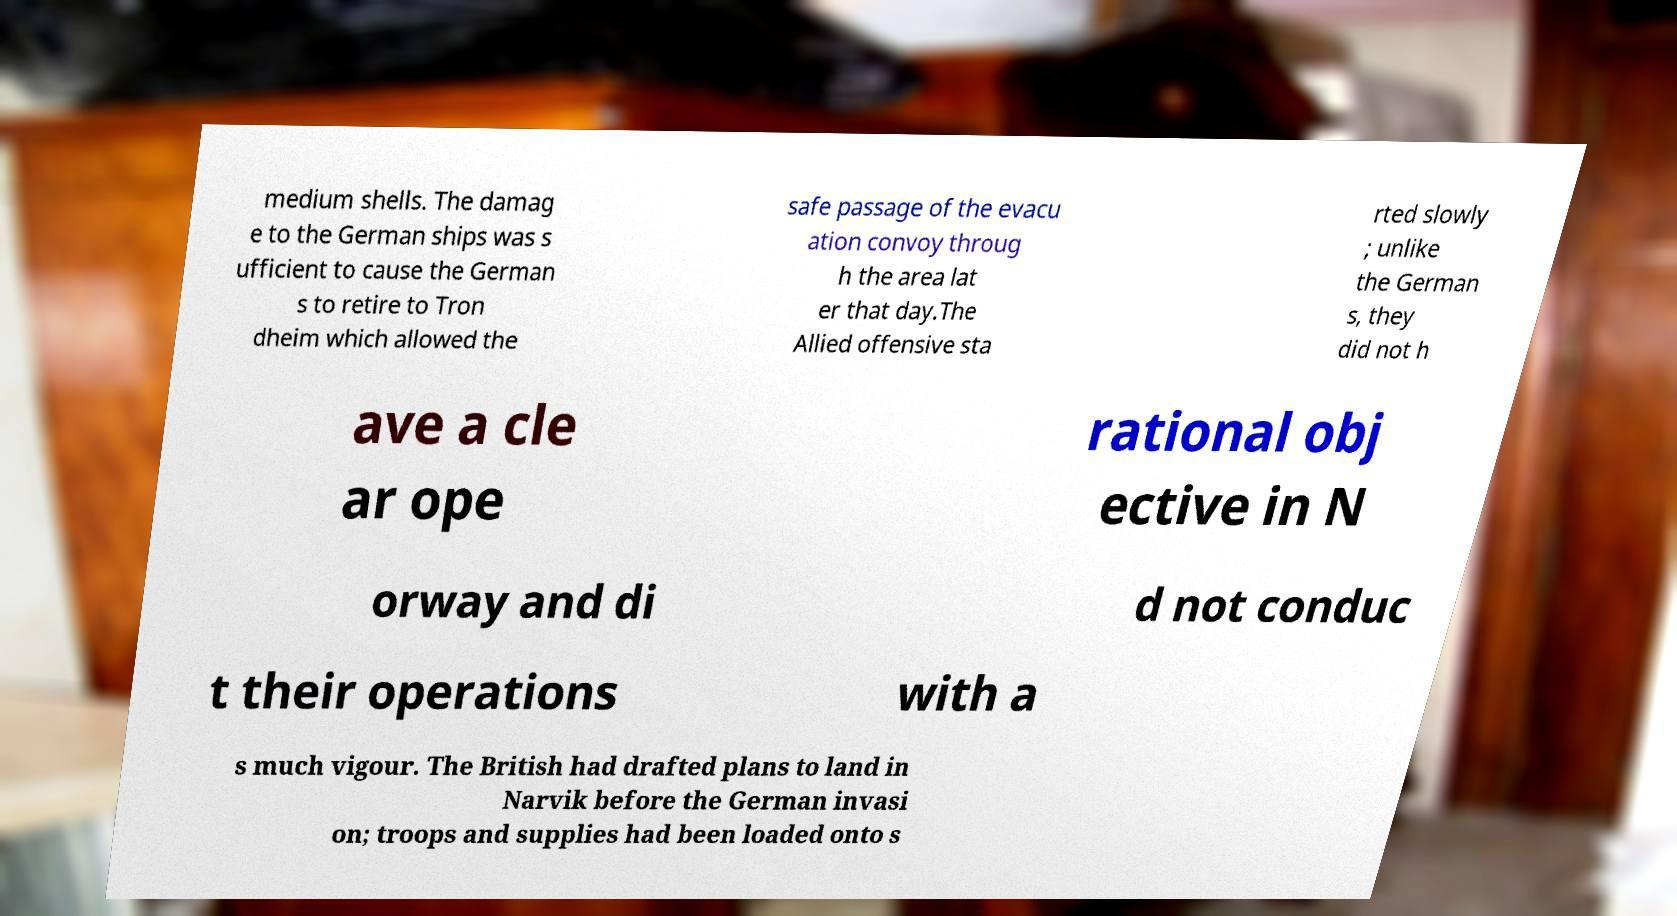Can you read and provide the text displayed in the image?This photo seems to have some interesting text. Can you extract and type it out for me? medium shells. The damag e to the German ships was s ufficient to cause the German s to retire to Tron dheim which allowed the safe passage of the evacu ation convoy throug h the area lat er that day.The Allied offensive sta rted slowly ; unlike the German s, they did not h ave a cle ar ope rational obj ective in N orway and di d not conduc t their operations with a s much vigour. The British had drafted plans to land in Narvik before the German invasi on; troops and supplies had been loaded onto s 